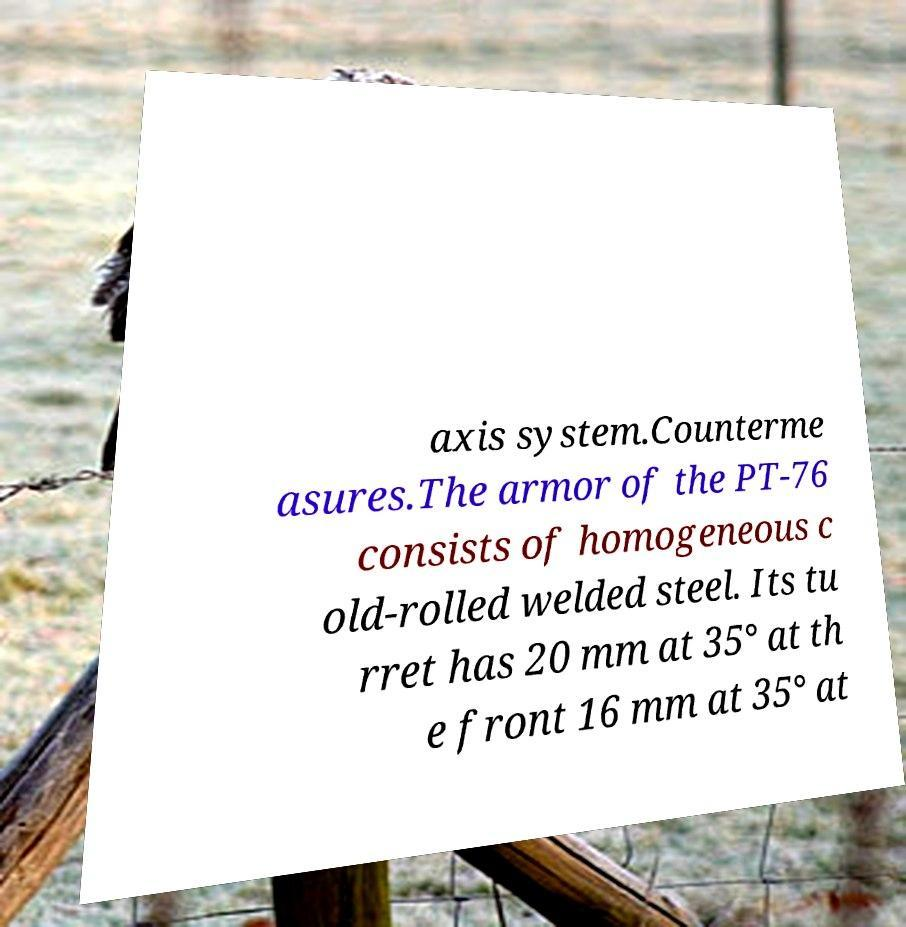Could you assist in decoding the text presented in this image and type it out clearly? axis system.Counterme asures.The armor of the PT-76 consists of homogeneous c old-rolled welded steel. Its tu rret has 20 mm at 35° at th e front 16 mm at 35° at 